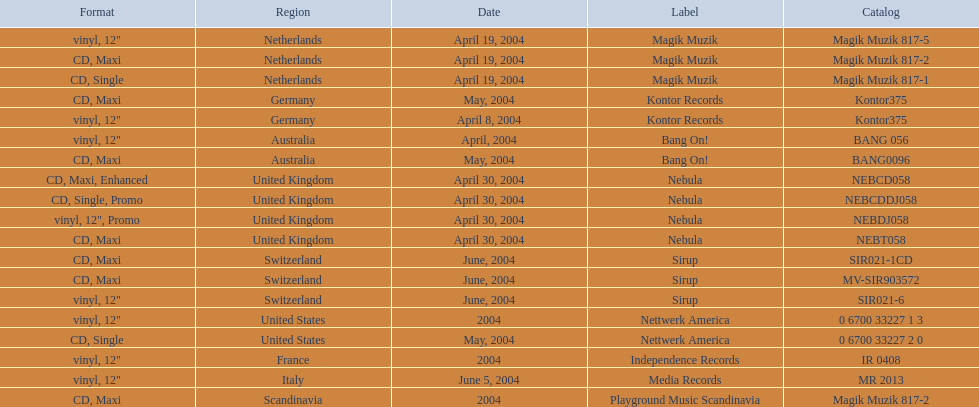What label was used by the netherlands in love comes again? Magik Muzik. What label was used in germany? Kontor Records. What label was used in france? Independence Records. 